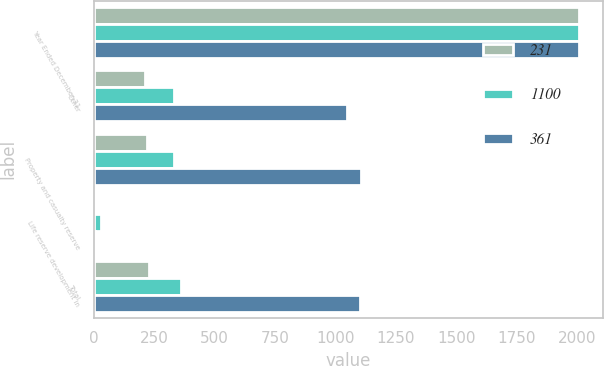Convert chart to OTSL. <chart><loc_0><loc_0><loc_500><loc_500><stacked_bar_chart><ecel><fcel>Year Ended December 31<fcel>Other<fcel>Property and casualty reserve<fcel>Life reserve development in<fcel>Total<nl><fcel>231<fcel>2007<fcel>213<fcel>220<fcel>11<fcel>231<nl><fcel>1100<fcel>2006<fcel>332<fcel>332<fcel>29<fcel>361<nl><fcel>361<fcel>2005<fcel>1047<fcel>1107<fcel>7<fcel>1100<nl></chart> 